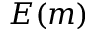Convert formula to latex. <formula><loc_0><loc_0><loc_500><loc_500>E ( m )</formula> 